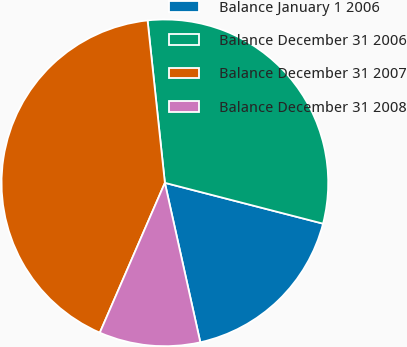Convert chart to OTSL. <chart><loc_0><loc_0><loc_500><loc_500><pie_chart><fcel>Balance January 1 2006<fcel>Balance December 31 2006<fcel>Balance December 31 2007<fcel>Balance December 31 2008<nl><fcel>17.5%<fcel>30.71%<fcel>41.79%<fcel>10.0%<nl></chart> 